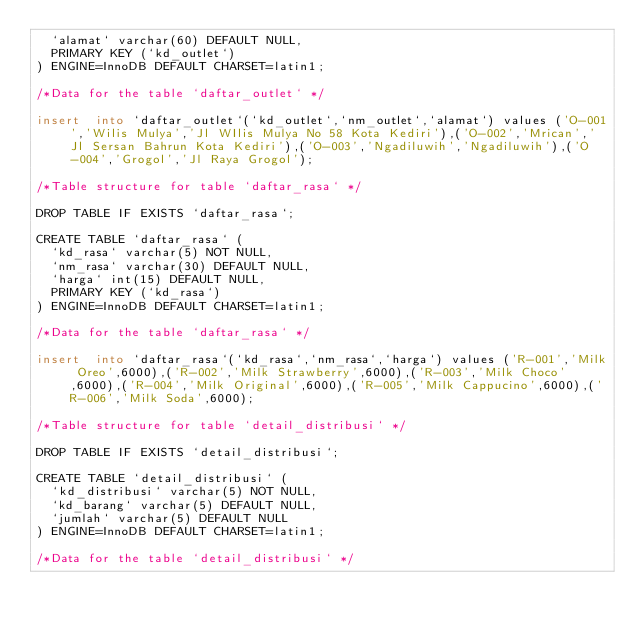Convert code to text. <code><loc_0><loc_0><loc_500><loc_500><_SQL_>  `alamat` varchar(60) DEFAULT NULL,
  PRIMARY KEY (`kd_outlet`)
) ENGINE=InnoDB DEFAULT CHARSET=latin1;

/*Data for the table `daftar_outlet` */

insert  into `daftar_outlet`(`kd_outlet`,`nm_outlet`,`alamat`) values ('O-001','Wilis Mulya','Jl WIlis Mulya No 58 Kota Kediri'),('O-002','Mrican','Jl Sersan Bahrun Kota Kediri'),('O-003','Ngadiluwih','Ngadiluwih'),('O-004','Grogol','Jl Raya Grogol');

/*Table structure for table `daftar_rasa` */

DROP TABLE IF EXISTS `daftar_rasa`;

CREATE TABLE `daftar_rasa` (
  `kd_rasa` varchar(5) NOT NULL,
  `nm_rasa` varchar(30) DEFAULT NULL,
  `harga` int(15) DEFAULT NULL,
  PRIMARY KEY (`kd_rasa`)
) ENGINE=InnoDB DEFAULT CHARSET=latin1;

/*Data for the table `daftar_rasa` */

insert  into `daftar_rasa`(`kd_rasa`,`nm_rasa`,`harga`) values ('R-001','Milk Oreo',6000),('R-002','Milk Strawberry',6000),('R-003','Milk Choco',6000),('R-004','Milk Original',6000),('R-005','Milk Cappucino',6000),('R-006','Milk Soda',6000);

/*Table structure for table `detail_distribusi` */

DROP TABLE IF EXISTS `detail_distribusi`;

CREATE TABLE `detail_distribusi` (
  `kd_distribusi` varchar(5) NOT NULL,
  `kd_barang` varchar(5) DEFAULT NULL,
  `jumlah` varchar(5) DEFAULT NULL
) ENGINE=InnoDB DEFAULT CHARSET=latin1;

/*Data for the table `detail_distribusi` */
</code> 